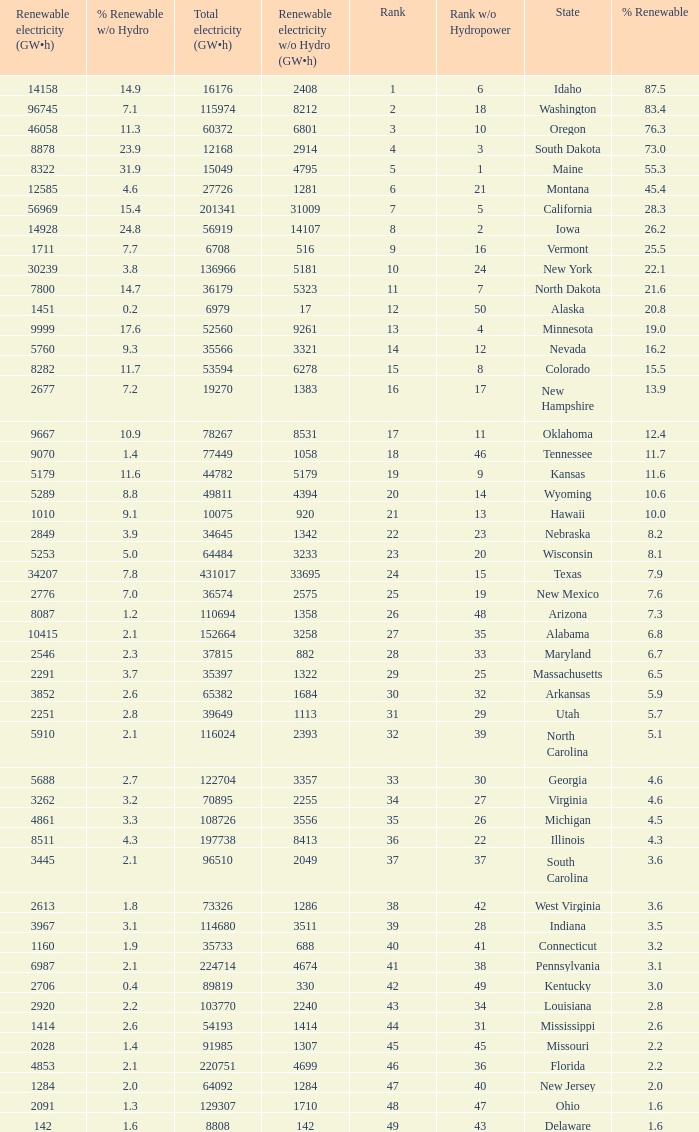Which states have renewable electricity equal to 9667 (gw×h)? Oklahoma. 